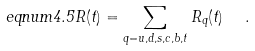Convert formula to latex. <formula><loc_0><loc_0><loc_500><loc_500>\ e q n u m { 4 . 5 } R ( t ) = \sum _ { q = u , d , s , c , b , t } R _ { q } ( t ) \ \ .</formula> 